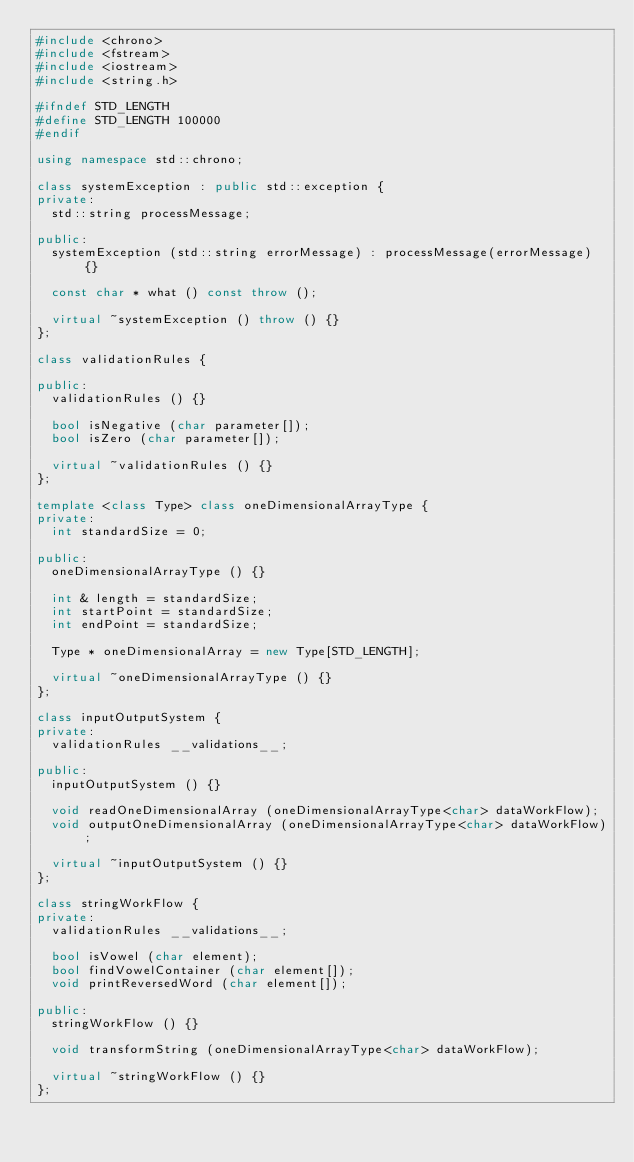Convert code to text. <code><loc_0><loc_0><loc_500><loc_500><_C++_>#include <chrono>
#include <fstream>
#include <iostream>
#include <string.h>

#ifndef STD_LENGTH
#define STD_LENGTH 100000
#endif

using namespace std::chrono;

class systemException : public std::exception {
private:
  std::string processMessage;

public:
  systemException (std::string errorMessage) : processMessage(errorMessage) {}

  const char * what () const throw ();

  virtual ~systemException () throw () {}
};

class validationRules {

public:
  validationRules () {}

  bool isNegative (char parameter[]);
  bool isZero (char parameter[]);

  virtual ~validationRules () {}
};

template <class Type> class oneDimensionalArrayType {
private:
  int standardSize = 0;

public:
  oneDimensionalArrayType () {}

  int & length = standardSize;
  int startPoint = standardSize;
  int endPoint = standardSize;

  Type * oneDimensionalArray = new Type[STD_LENGTH];

  virtual ~oneDimensionalArrayType () {}
};

class inputOutputSystem {
private:
  validationRules __validations__;

public:
  inputOutputSystem () {}

  void readOneDimensionalArray (oneDimensionalArrayType<char> dataWorkFlow);
  void outputOneDimensionalArray (oneDimensionalArrayType<char> dataWorkFlow);

  virtual ~inputOutputSystem () {}
};

class stringWorkFlow {
private:
  validationRules __validations__;

  bool isVowel (char element);
  bool findVowelContainer (char element[]);
  void printReversedWord (char element[]);

public:
  stringWorkFlow () {}

  void transformString (oneDimensionalArrayType<char> dataWorkFlow);

  virtual ~stringWorkFlow () {}
};</code> 